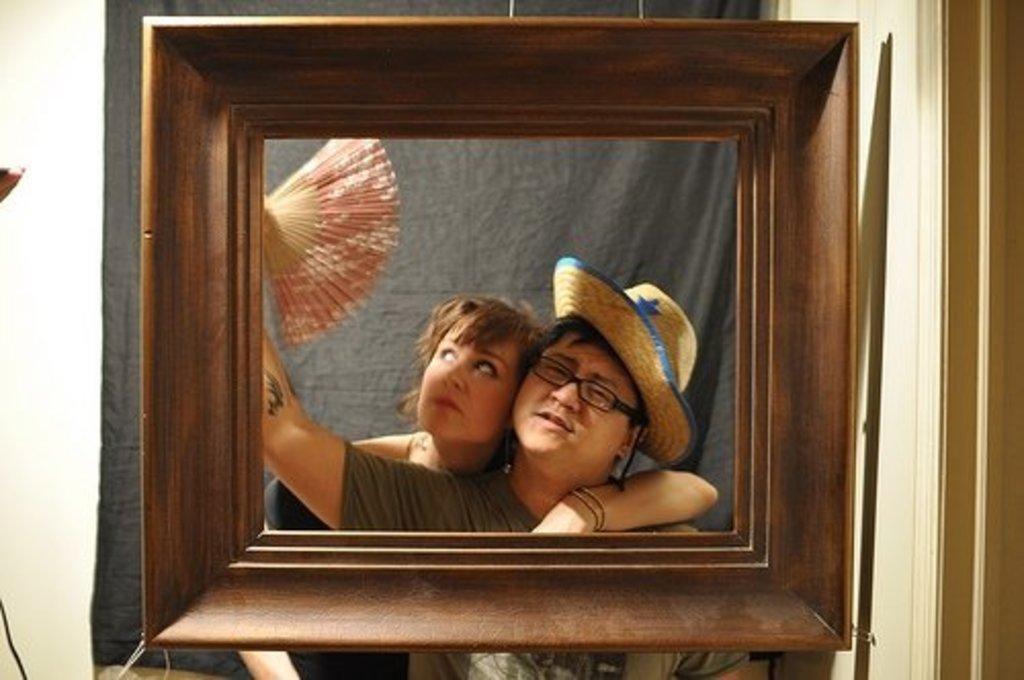Describe this image in one or two sentences. In this image there is a frame, behind the frame there is a man and women are posing for a photograph. 